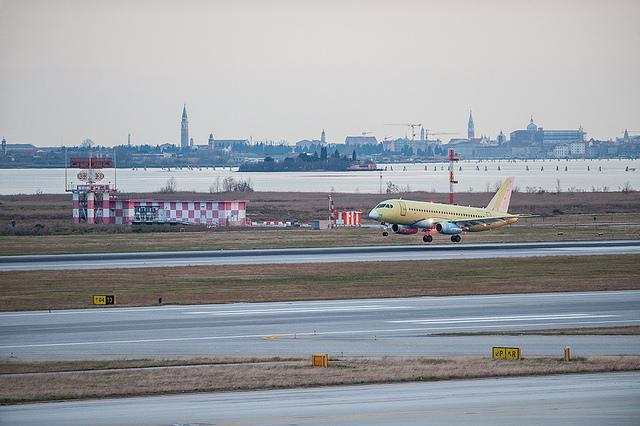What model plane is this?
Write a very short answer. Passenger. Is one of the buildings checkered in color?
Answer briefly. Yes. Are the planes in flight?
Concise answer only. Yes. Is the plane in motion?
Write a very short answer. Yes. What airport is this plane landing at?
Give a very brief answer. Unknown. Is the airplane landing?
Write a very short answer. Yes. 